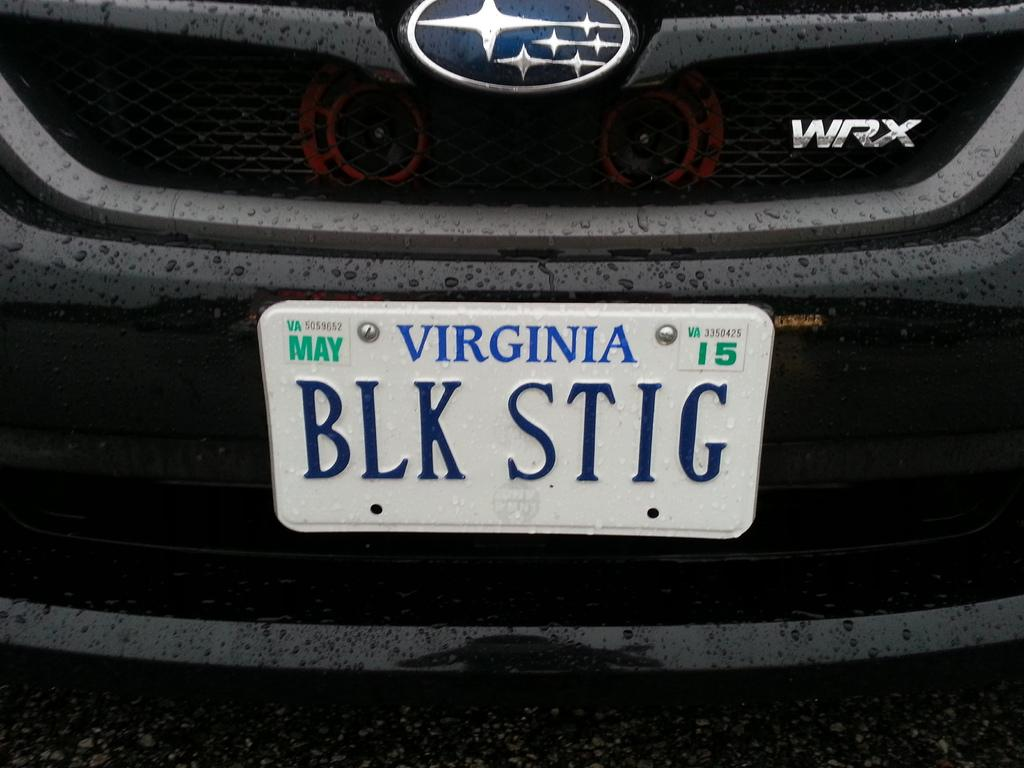Provide a one-sentence caption for the provided image. A car has the Virginia license plate BLK STIG. 